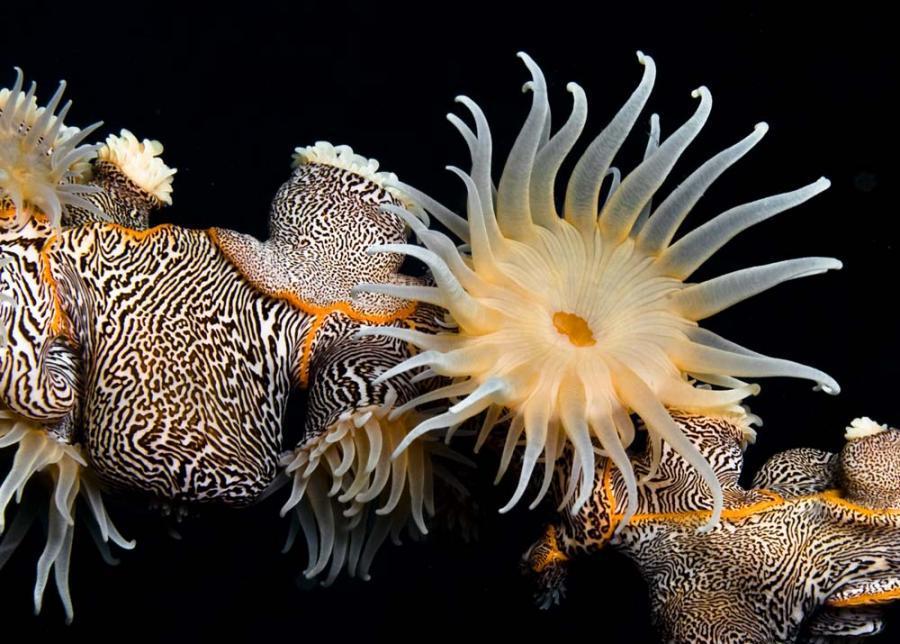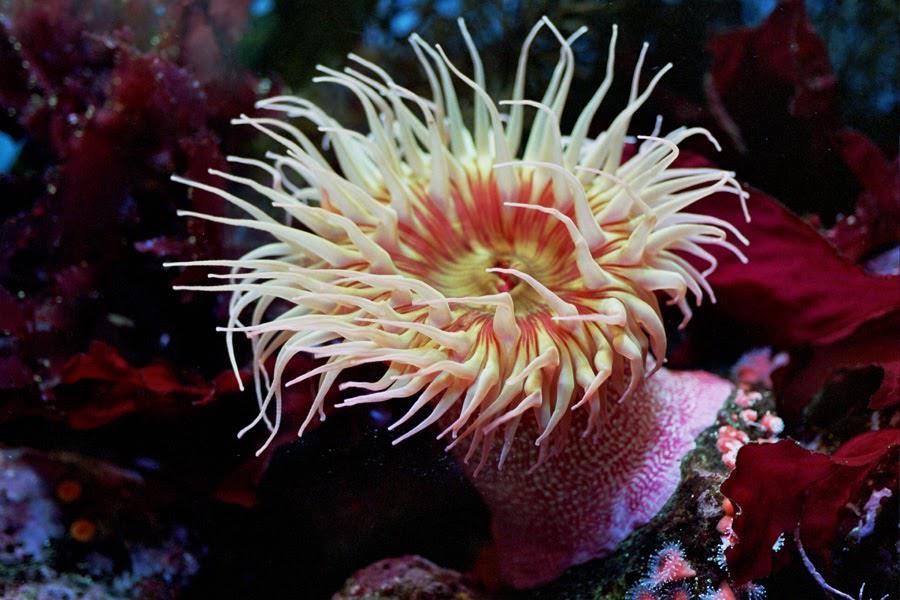The first image is the image on the left, the second image is the image on the right. Considering the images on both sides, is "The creature in the image on the left has black and white markings." valid? Answer yes or no. Yes. 